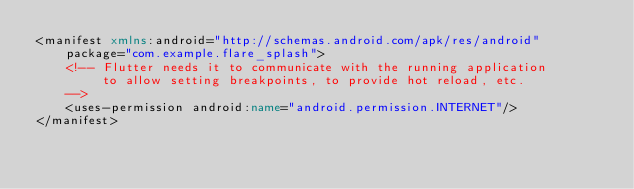Convert code to text. <code><loc_0><loc_0><loc_500><loc_500><_XML_><manifest xmlns:android="http://schemas.android.com/apk/res/android"
    package="com.example.flare_splash">
    <!-- Flutter needs it to communicate with the running application
         to allow setting breakpoints, to provide hot reload, etc.
    -->
    <uses-permission android:name="android.permission.INTERNET"/>
</manifest>
</code> 